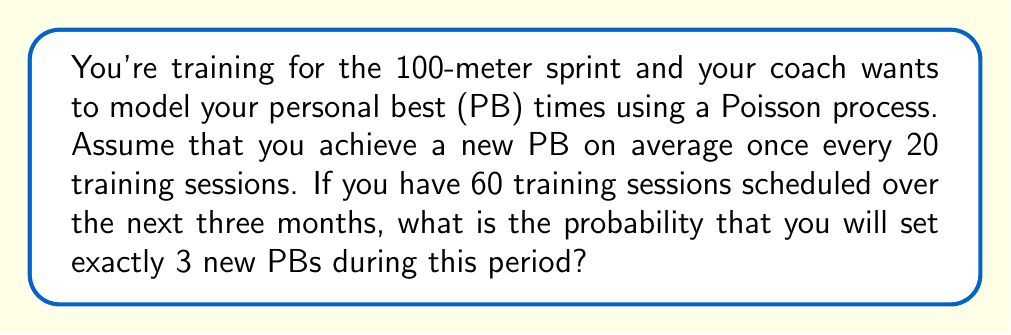What is the answer to this math problem? Let's approach this step-by-step:

1) We're dealing with a Poisson process, where the number of events (new PBs) in a fixed interval follows a Poisson distribution.

2) The Poisson distribution is characterized by its rate parameter λ (lambda), which represents the average number of events in the interval.

3) In this case:
   - The average rate is 1 PB per 20 sessions
   - We have 60 sessions total
   
   So, λ = 60 / 20 = 3

4) The probability of exactly k events occurring in a Poisson process is given by the Poisson probability mass function:

   $$P(X = k) = \frac{e^{-λ}λ^k}{k!}$$

5) We want the probability of exactly 3 PBs, so k = 3:

   $$P(X = 3) = \frac{e^{-3}3^3}{3!}$$

6) Let's calculate this step-by-step:
   
   $$\frac{e^{-3} \cdot 27}{6}$$
   
   $$\frac{0.0497871 \cdot 27}{6}$$
   
   $$\frac{1.34425}{6}$$
   
   $$0.224042$$

7) Rounding to four decimal places: 0.2240

Thus, the probability of setting exactly 3 new PBs in 60 training sessions is approximately 0.2240 or 22.40%.
Answer: 0.2240 